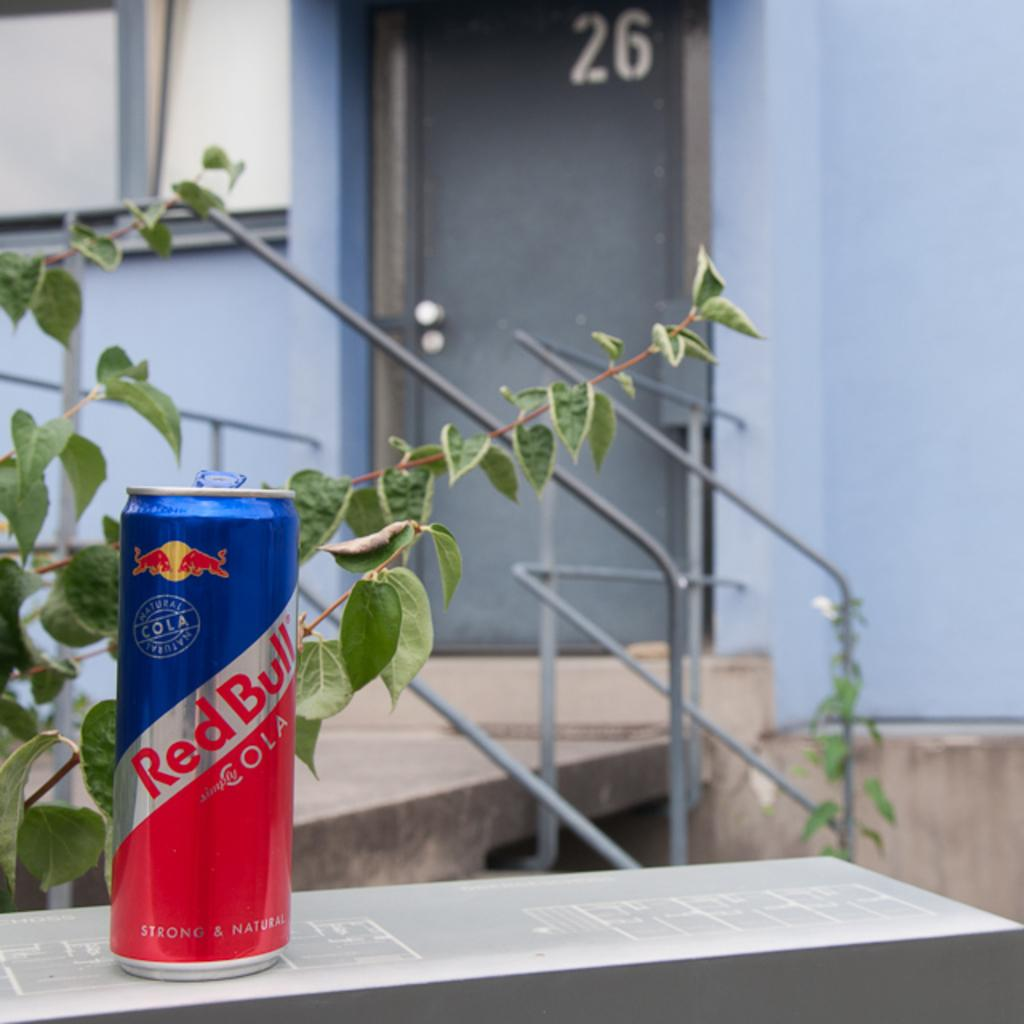What is the main object in the front of the image? There is a red bull tin in the front of the image. What type of vegetation is on the left side of the image? There is a plant on the left side of the image. What can be seen in the background of the image? There is a wall and a door in the background of the image. What news headline is visible on the red bull tin in the image? There is no news headline visible on the red bull tin in the image. 